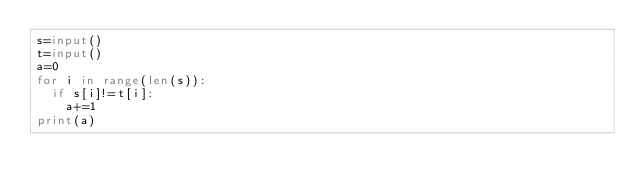<code> <loc_0><loc_0><loc_500><loc_500><_Python_>s=input()
t=input()
a=0
for i in range(len(s)):
  if s[i]!=t[i]:
    a+=1
print(a)</code> 